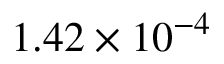<formula> <loc_0><loc_0><loc_500><loc_500>1 . 4 2 \times 1 0 ^ { - 4 }</formula> 